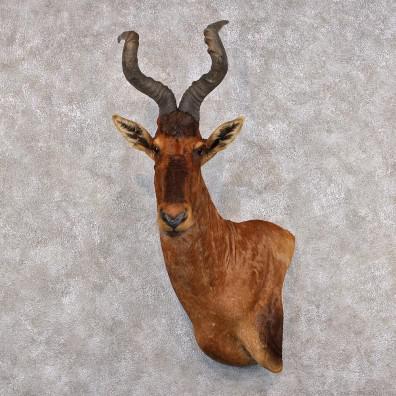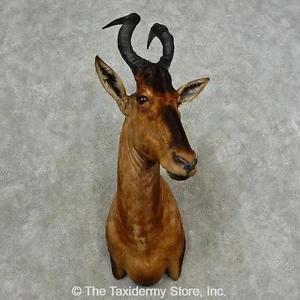The first image is the image on the left, the second image is the image on the right. For the images displayed, is the sentence "At least one of the animals is mounted on a grey marblized wall." factually correct? Answer yes or no. Yes. 